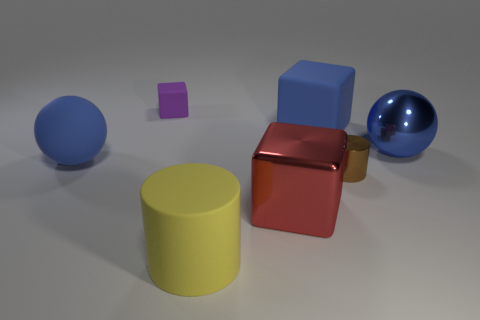Add 1 large green metallic spheres. How many objects exist? 8 Subtract all purple matte blocks. How many blocks are left? 2 Subtract all yellow cylinders. How many cylinders are left? 1 Subtract all blocks. How many objects are left? 4 Subtract 1 spheres. How many spheres are left? 1 Subtract all yellow blocks. How many blue cylinders are left? 0 Subtract all big matte cubes. Subtract all big brown rubber cubes. How many objects are left? 6 Add 4 brown metallic cylinders. How many brown metallic cylinders are left? 5 Add 7 shiny things. How many shiny things exist? 10 Subtract 0 blue cylinders. How many objects are left? 7 